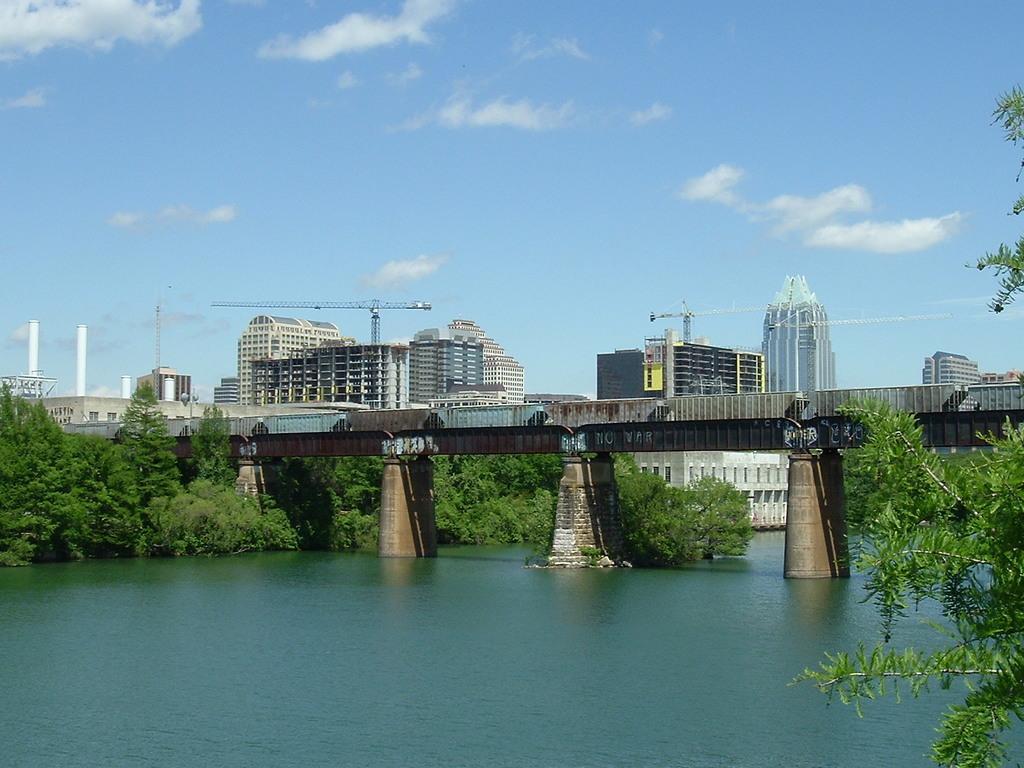How would you summarize this image in a sentence or two? In this picture there is a bridge and there are few trees and water below the bridge and there are buildings and cranes in the background. 